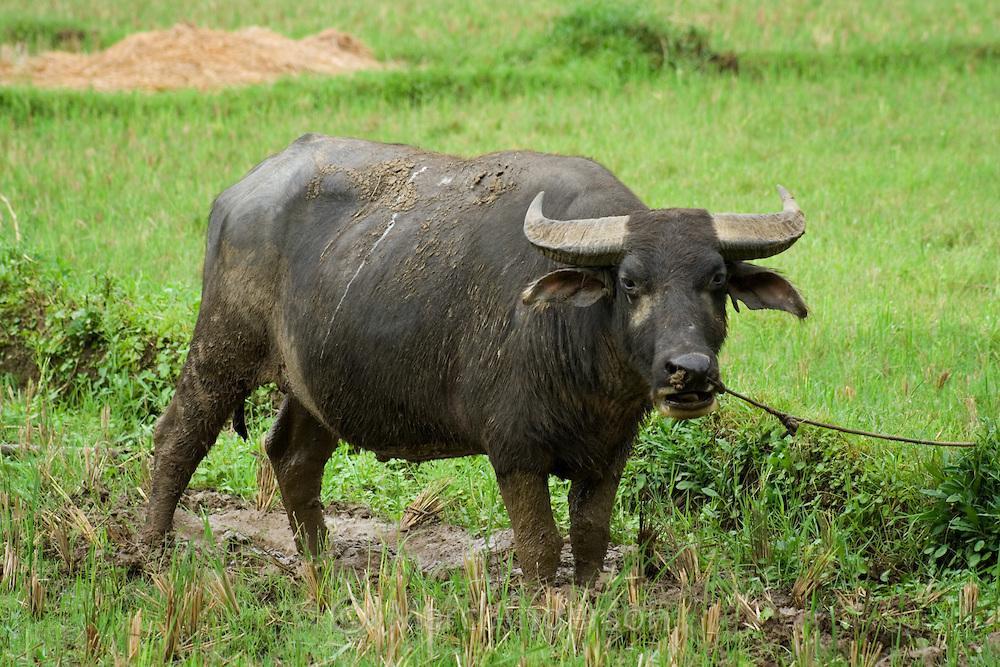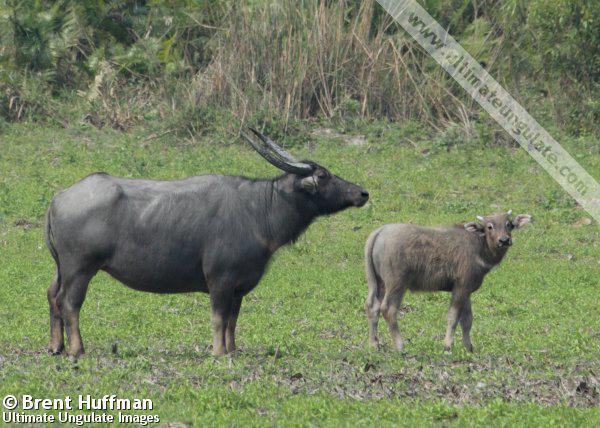The first image is the image on the left, the second image is the image on the right. Examine the images to the left and right. Is the description "In one image, a water buffalo is submerged in water with its head and upper body showing." accurate? Answer yes or no. No. The first image is the image on the left, the second image is the image on the right. For the images displayed, is the sentence "An image shows exactly one water buffalo at least waist deep in water." factually correct? Answer yes or no. No. The first image is the image on the left, the second image is the image on the right. For the images shown, is this caption "the image on the right contains a water buffalo whose body is submerged in water." true? Answer yes or no. No. The first image is the image on the left, the second image is the image on the right. Given the left and right images, does the statement "A single horned animal is in the water." hold true? Answer yes or no. No. 